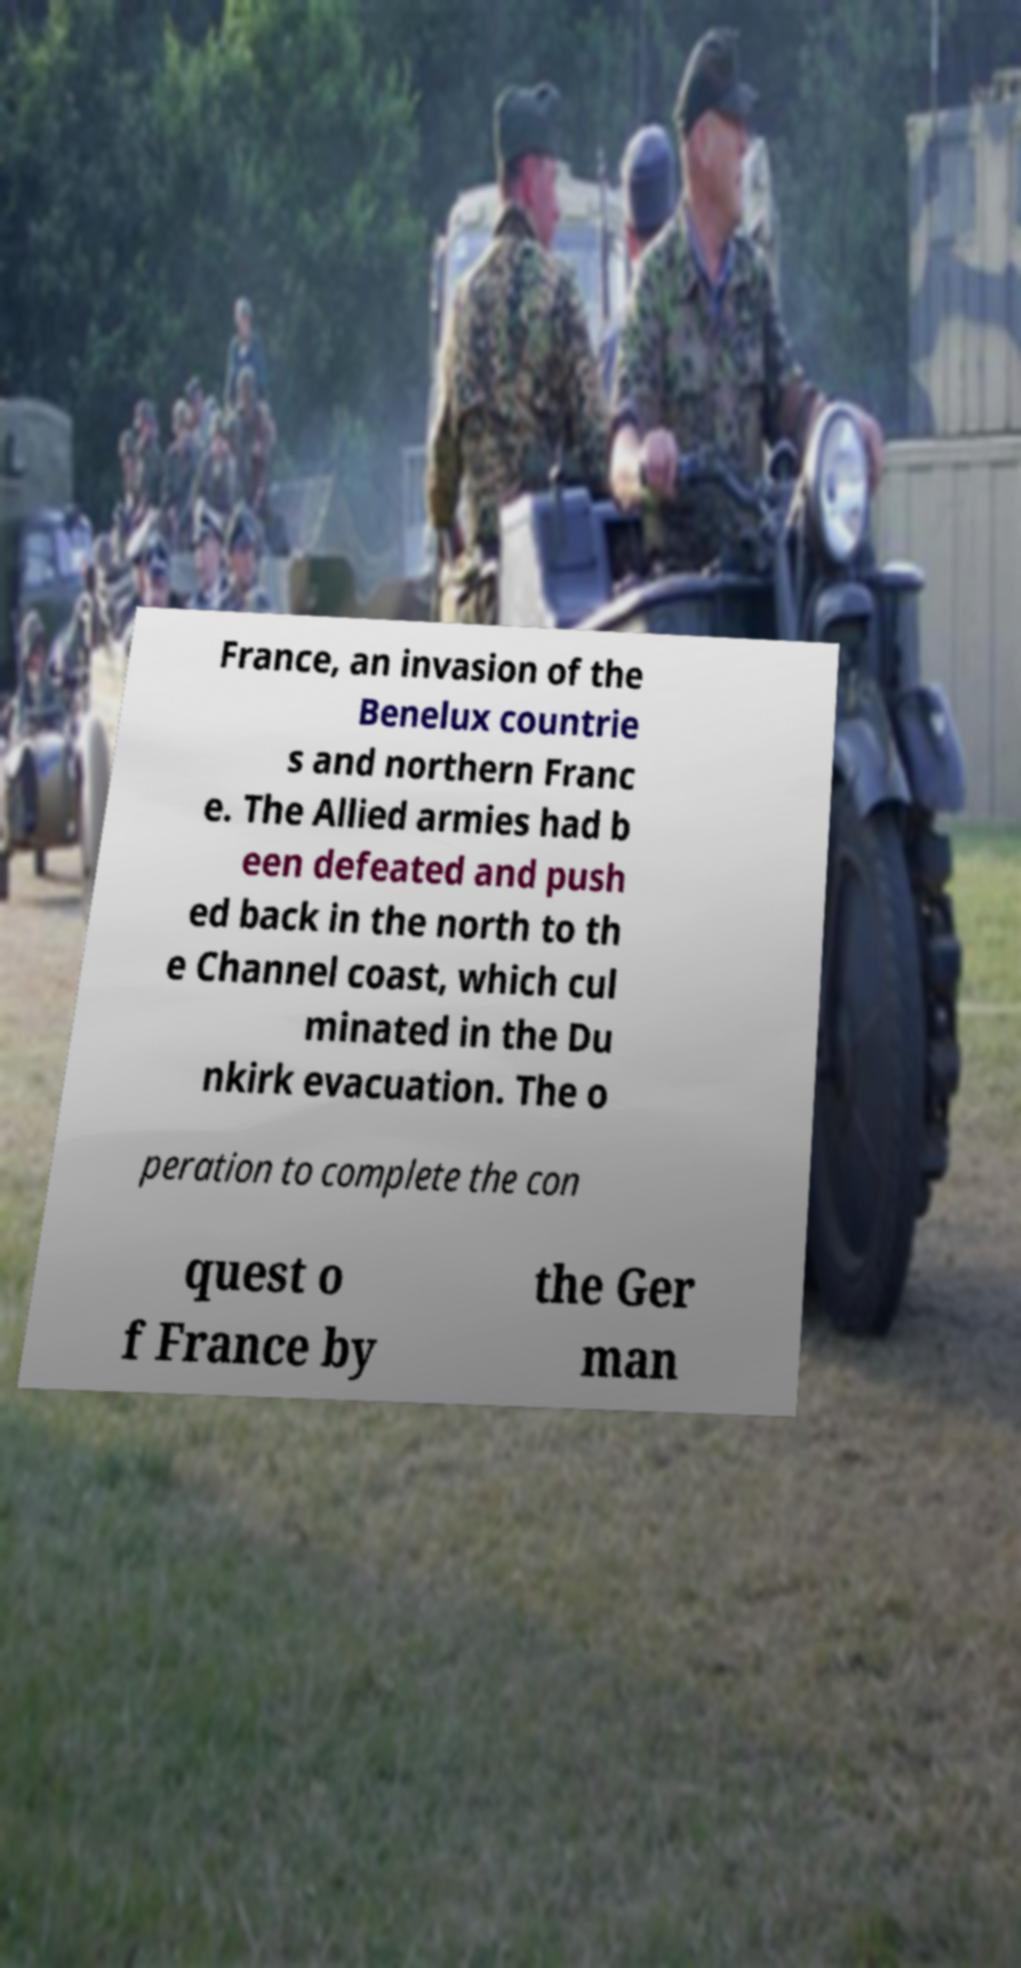Could you extract and type out the text from this image? France, an invasion of the Benelux countrie s and northern Franc e. The Allied armies had b een defeated and push ed back in the north to th e Channel coast, which cul minated in the Du nkirk evacuation. The o peration to complete the con quest o f France by the Ger man 